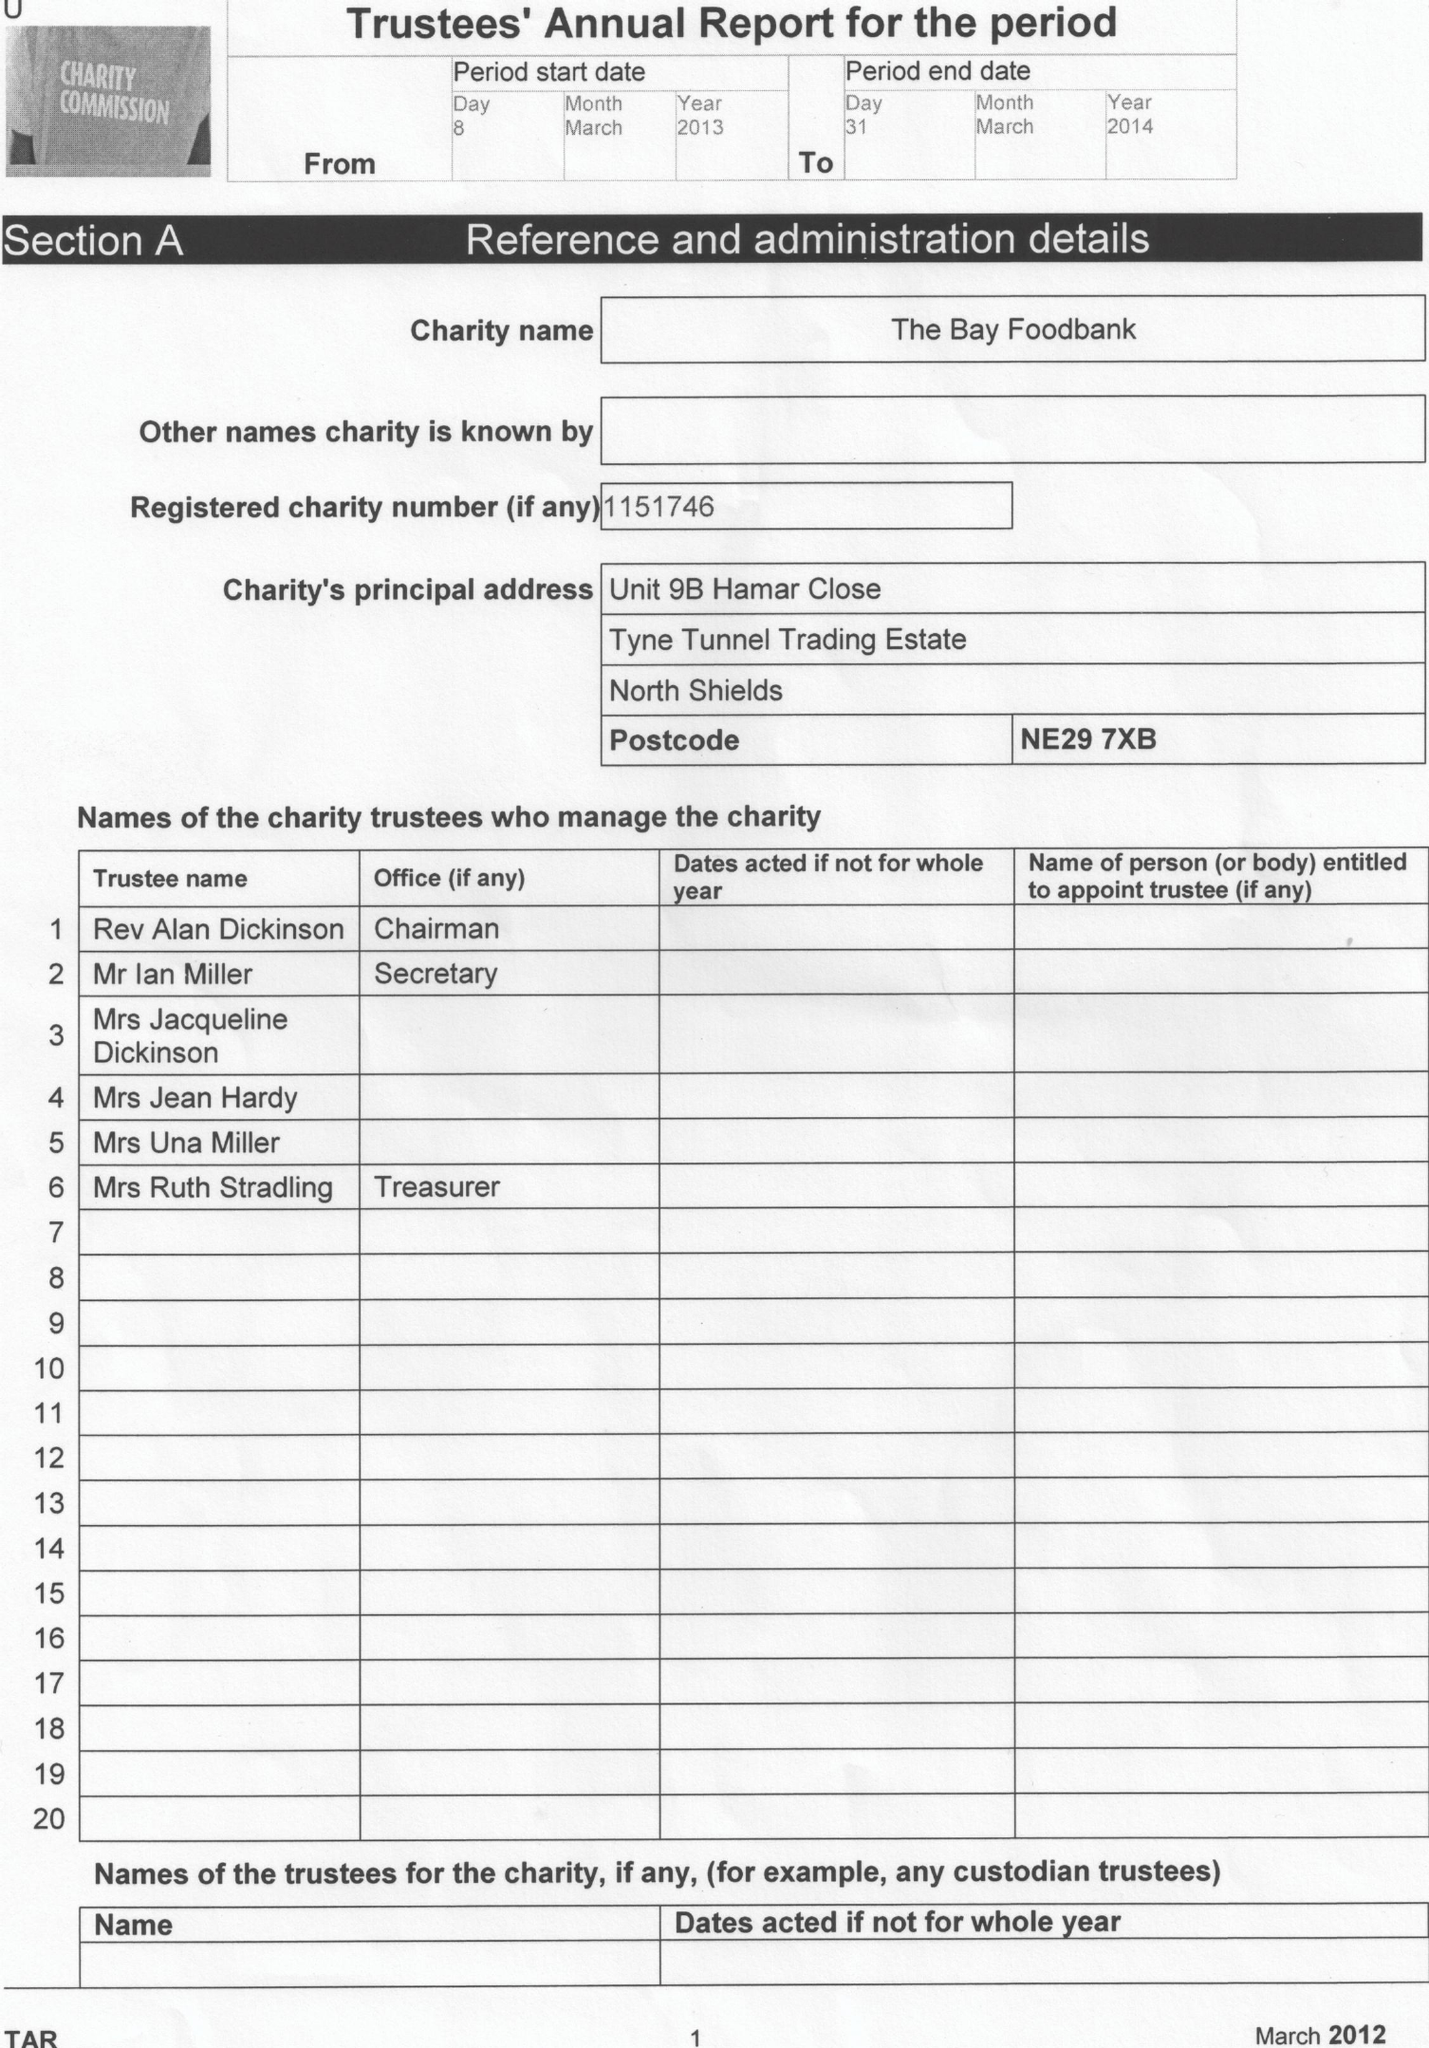What is the value for the address__street_line?
Answer the question using a single word or phrase. None 